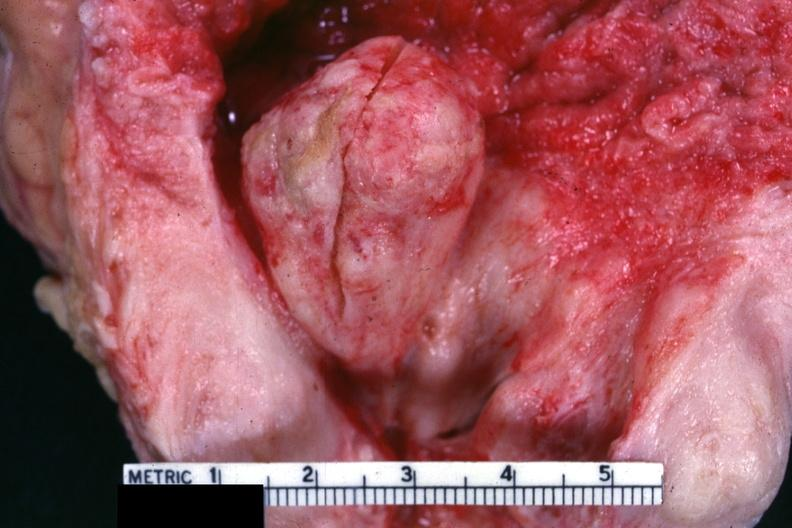s hyperplasia present?
Answer the question using a single word or phrase. Yes 